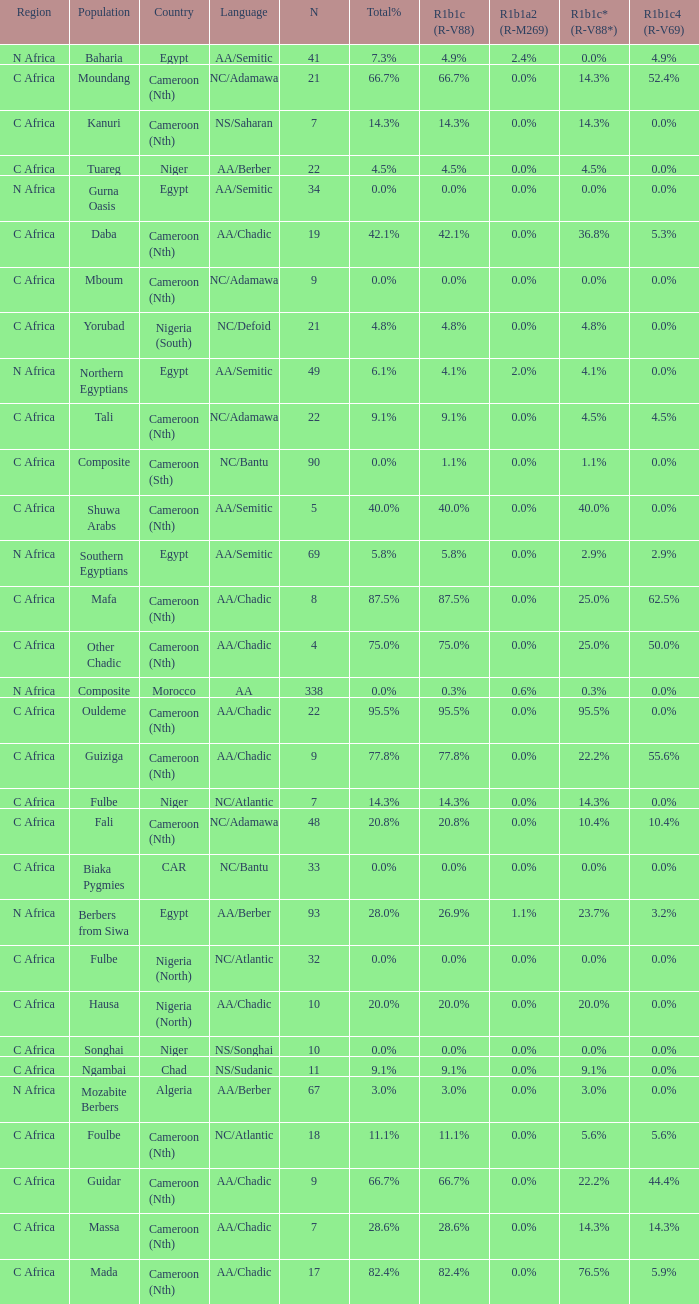What languages are spoken in Niger with r1b1c (r-v88) of 0.0%? NS/Songhai. Would you mind parsing the complete table? {'header': ['Region', 'Population', 'Country', 'Language', 'N', 'Total%', 'R1b1c (R-V88)', 'R1b1a2 (R-M269)', 'R1b1c* (R-V88*)', 'R1b1c4 (R-V69)'], 'rows': [['N Africa', 'Baharia', 'Egypt', 'AA/Semitic', '41', '7.3%', '4.9%', '2.4%', '0.0%', '4.9%'], ['C Africa', 'Moundang', 'Cameroon (Nth)', 'NC/Adamawa', '21', '66.7%', '66.7%', '0.0%', '14.3%', '52.4%'], ['C Africa', 'Kanuri', 'Cameroon (Nth)', 'NS/Saharan', '7', '14.3%', '14.3%', '0.0%', '14.3%', '0.0%'], ['C Africa', 'Tuareg', 'Niger', 'AA/Berber', '22', '4.5%', '4.5%', '0.0%', '4.5%', '0.0%'], ['N Africa', 'Gurna Oasis', 'Egypt', 'AA/Semitic', '34', '0.0%', '0.0%', '0.0%', '0.0%', '0.0%'], ['C Africa', 'Daba', 'Cameroon (Nth)', 'AA/Chadic', '19', '42.1%', '42.1%', '0.0%', '36.8%', '5.3%'], ['C Africa', 'Mboum', 'Cameroon (Nth)', 'NC/Adamawa', '9', '0.0%', '0.0%', '0.0%', '0.0%', '0.0%'], ['C Africa', 'Yorubad', 'Nigeria (South)', 'NC/Defoid', '21', '4.8%', '4.8%', '0.0%', '4.8%', '0.0%'], ['N Africa', 'Northern Egyptians', 'Egypt', 'AA/Semitic', '49', '6.1%', '4.1%', '2.0%', '4.1%', '0.0%'], ['C Africa', 'Tali', 'Cameroon (Nth)', 'NC/Adamawa', '22', '9.1%', '9.1%', '0.0%', '4.5%', '4.5%'], ['C Africa', 'Composite', 'Cameroon (Sth)', 'NC/Bantu', '90', '0.0%', '1.1%', '0.0%', '1.1%', '0.0%'], ['C Africa', 'Shuwa Arabs', 'Cameroon (Nth)', 'AA/Semitic', '5', '40.0%', '40.0%', '0.0%', '40.0%', '0.0%'], ['N Africa', 'Southern Egyptians', 'Egypt', 'AA/Semitic', '69', '5.8%', '5.8%', '0.0%', '2.9%', '2.9%'], ['C Africa', 'Mafa', 'Cameroon (Nth)', 'AA/Chadic', '8', '87.5%', '87.5%', '0.0%', '25.0%', '62.5%'], ['C Africa', 'Other Chadic', 'Cameroon (Nth)', 'AA/Chadic', '4', '75.0%', '75.0%', '0.0%', '25.0%', '50.0%'], ['N Africa', 'Composite', 'Morocco', 'AA', '338', '0.0%', '0.3%', '0.6%', '0.3%', '0.0%'], ['C Africa', 'Ouldeme', 'Cameroon (Nth)', 'AA/Chadic', '22', '95.5%', '95.5%', '0.0%', '95.5%', '0.0%'], ['C Africa', 'Guiziga', 'Cameroon (Nth)', 'AA/Chadic', '9', '77.8%', '77.8%', '0.0%', '22.2%', '55.6%'], ['C Africa', 'Fulbe', 'Niger', 'NC/Atlantic', '7', '14.3%', '14.3%', '0.0%', '14.3%', '0.0%'], ['C Africa', 'Fali', 'Cameroon (Nth)', 'NC/Adamawa', '48', '20.8%', '20.8%', '0.0%', '10.4%', '10.4%'], ['C Africa', 'Biaka Pygmies', 'CAR', 'NC/Bantu', '33', '0.0%', '0.0%', '0.0%', '0.0%', '0.0%'], ['N Africa', 'Berbers from Siwa', 'Egypt', 'AA/Berber', '93', '28.0%', '26.9%', '1.1%', '23.7%', '3.2%'], ['C Africa', 'Fulbe', 'Nigeria (North)', 'NC/Atlantic', '32', '0.0%', '0.0%', '0.0%', '0.0%', '0.0%'], ['C Africa', 'Hausa', 'Nigeria (North)', 'AA/Chadic', '10', '20.0%', '20.0%', '0.0%', '20.0%', '0.0%'], ['C Africa', 'Songhai', 'Niger', 'NS/Songhai', '10', '0.0%', '0.0%', '0.0%', '0.0%', '0.0%'], ['C Africa', 'Ngambai', 'Chad', 'NS/Sudanic', '11', '9.1%', '9.1%', '0.0%', '9.1%', '0.0%'], ['N Africa', 'Mozabite Berbers', 'Algeria', 'AA/Berber', '67', '3.0%', '3.0%', '0.0%', '3.0%', '0.0%'], ['C Africa', 'Foulbe', 'Cameroon (Nth)', 'NC/Atlantic', '18', '11.1%', '11.1%', '0.0%', '5.6%', '5.6%'], ['C Africa', 'Guidar', 'Cameroon (Nth)', 'AA/Chadic', '9', '66.7%', '66.7%', '0.0%', '22.2%', '44.4%'], ['C Africa', 'Massa', 'Cameroon (Nth)', 'AA/Chadic', '7', '28.6%', '28.6%', '0.0%', '14.3%', '14.3%'], ['C Africa', 'Mada', 'Cameroon (Nth)', 'AA/Chadic', '17', '82.4%', '82.4%', '0.0%', '76.5%', '5.9%']]} 